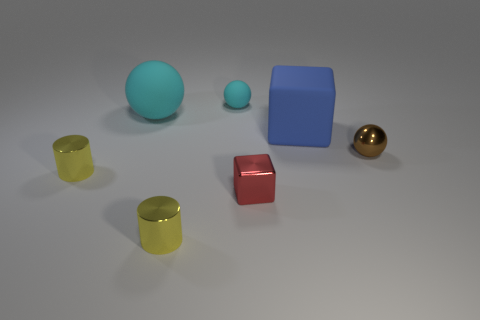Add 2 blue blocks. How many objects exist? 9 Subtract all spheres. How many objects are left? 4 Subtract 0 gray spheres. How many objects are left? 7 Subtract all blue objects. Subtract all small yellow metal things. How many objects are left? 4 Add 2 brown metal balls. How many brown metal balls are left? 3 Add 7 tiny cyan matte things. How many tiny cyan matte things exist? 8 